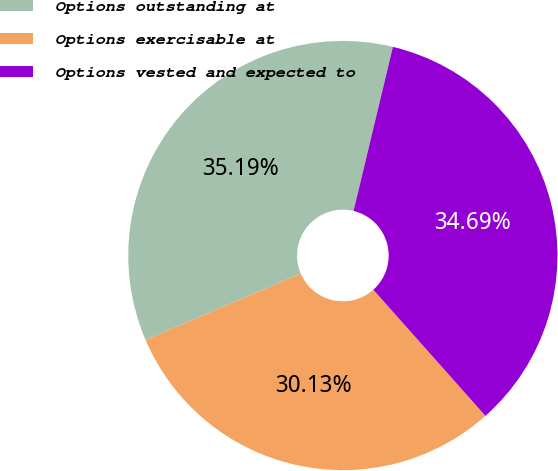Convert chart to OTSL. <chart><loc_0><loc_0><loc_500><loc_500><pie_chart><fcel>Options outstanding at<fcel>Options exercisable at<fcel>Options vested and expected to<nl><fcel>35.19%<fcel>30.13%<fcel>34.69%<nl></chart> 